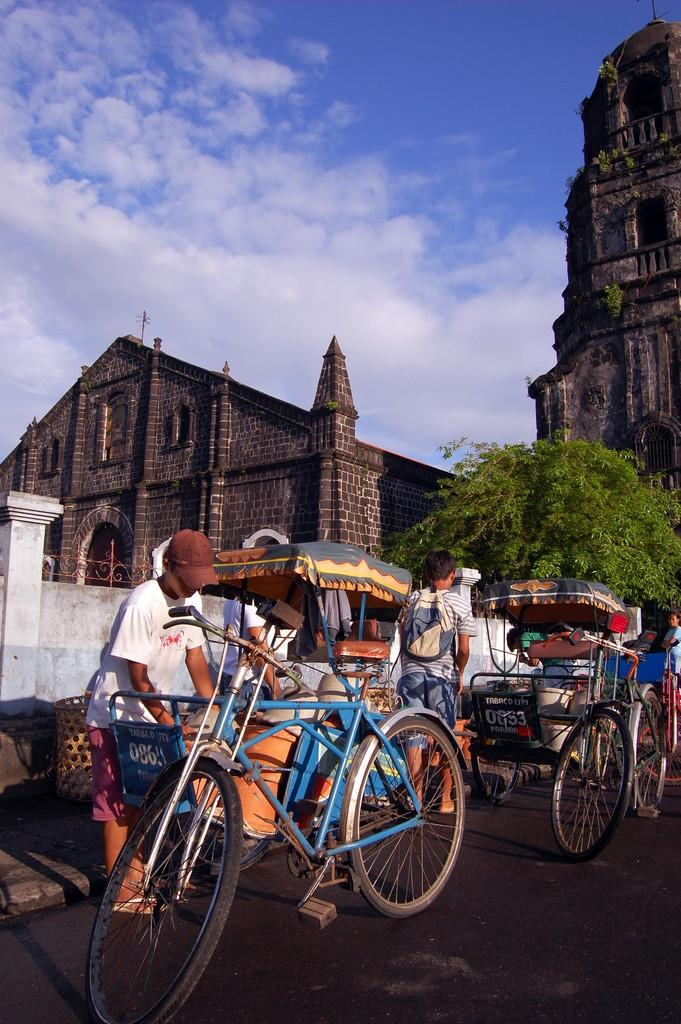Who or what can be seen in the image? There are people in the image. What mode of transportation is present on the road in the image? There are rickshaws on the road in the image. What can be seen in the background of the image? There are buildings and trees in the background of the image. What is visible in the sky at the top of the image? There are clouds visible in the sky at the top of the image. What type of meal is being served in the image? There is no meal present in the image; it features people, rickshaws, buildings, trees, and clouds. 